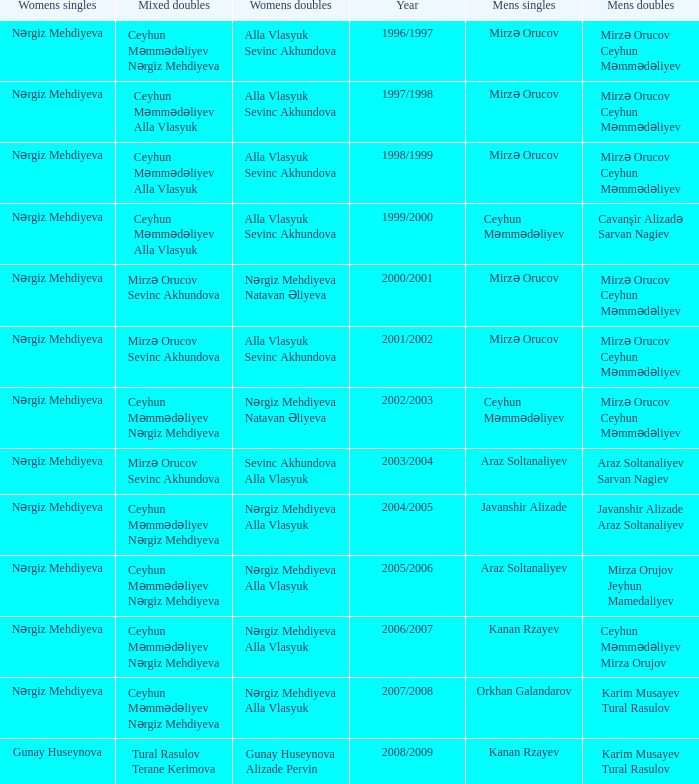What are all values for Womens Doubles in the year 2000/2001? Nərgiz Mehdiyeva Natavan Əliyeva. 